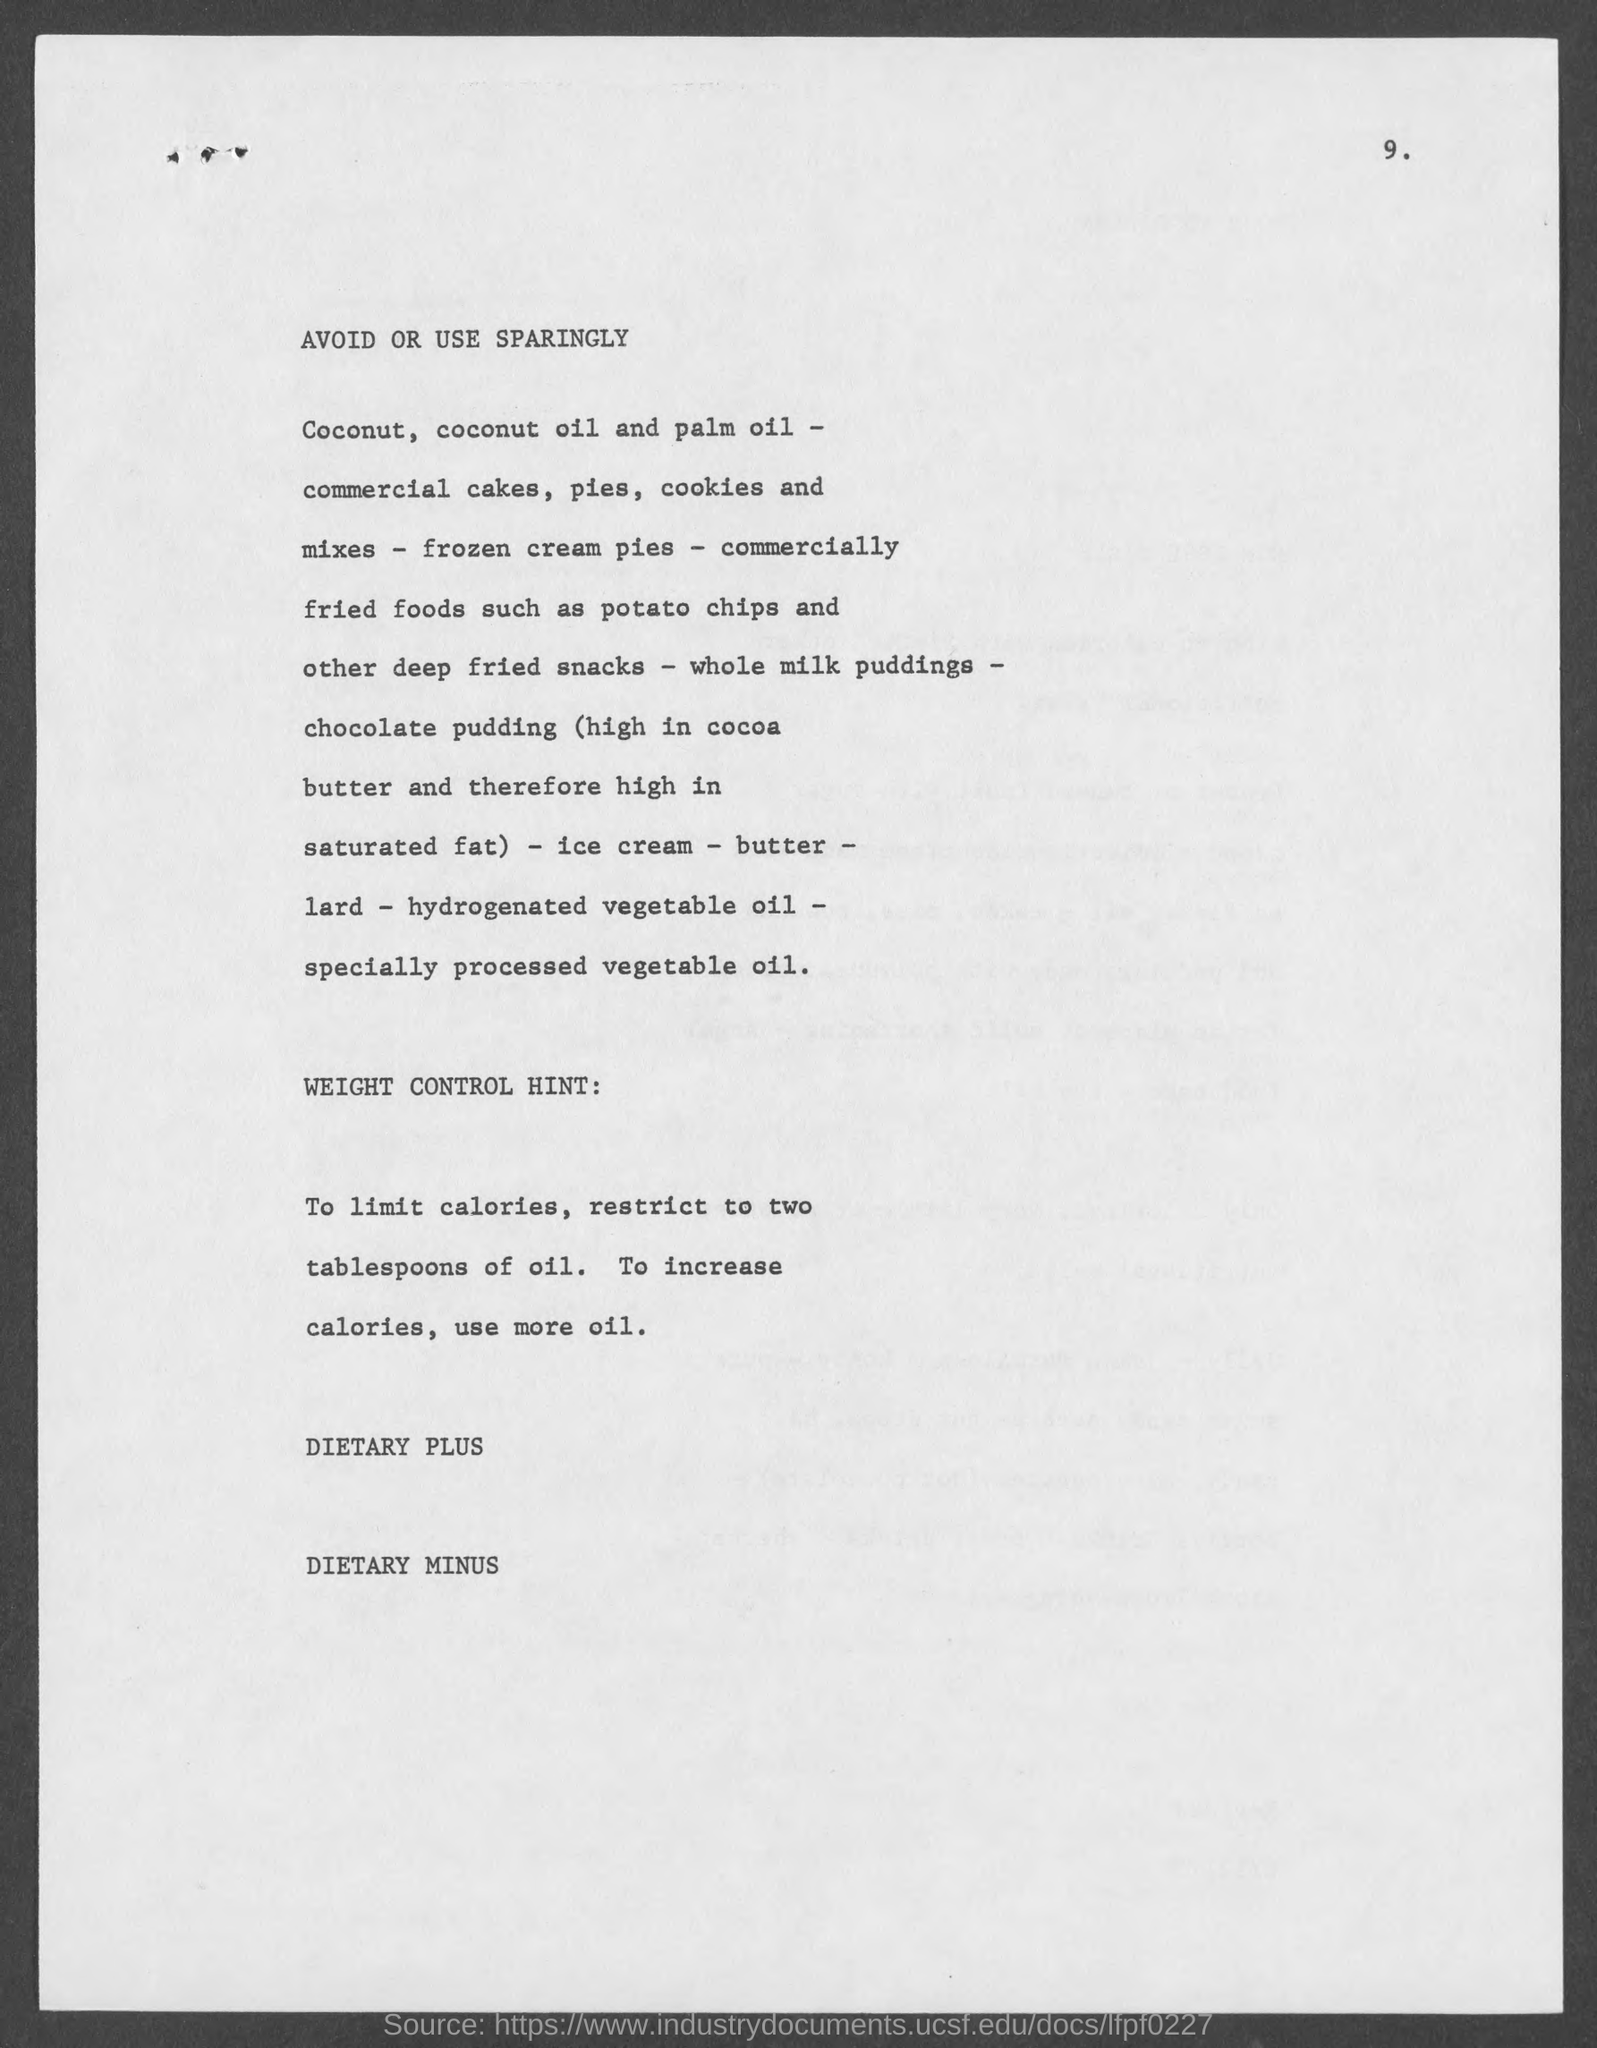What is the page number?
Make the answer very short. 9. What is the first title in the document?
Your answer should be very brief. Avoid or use sparingly. What is the second title in the document?
Ensure brevity in your answer.  WEIGHT CONTROL HINT. What is the third title in the document?
Your answer should be compact. Dietary plus. What is the fourth title in the document?
Your answer should be very brief. Dietary minus. 